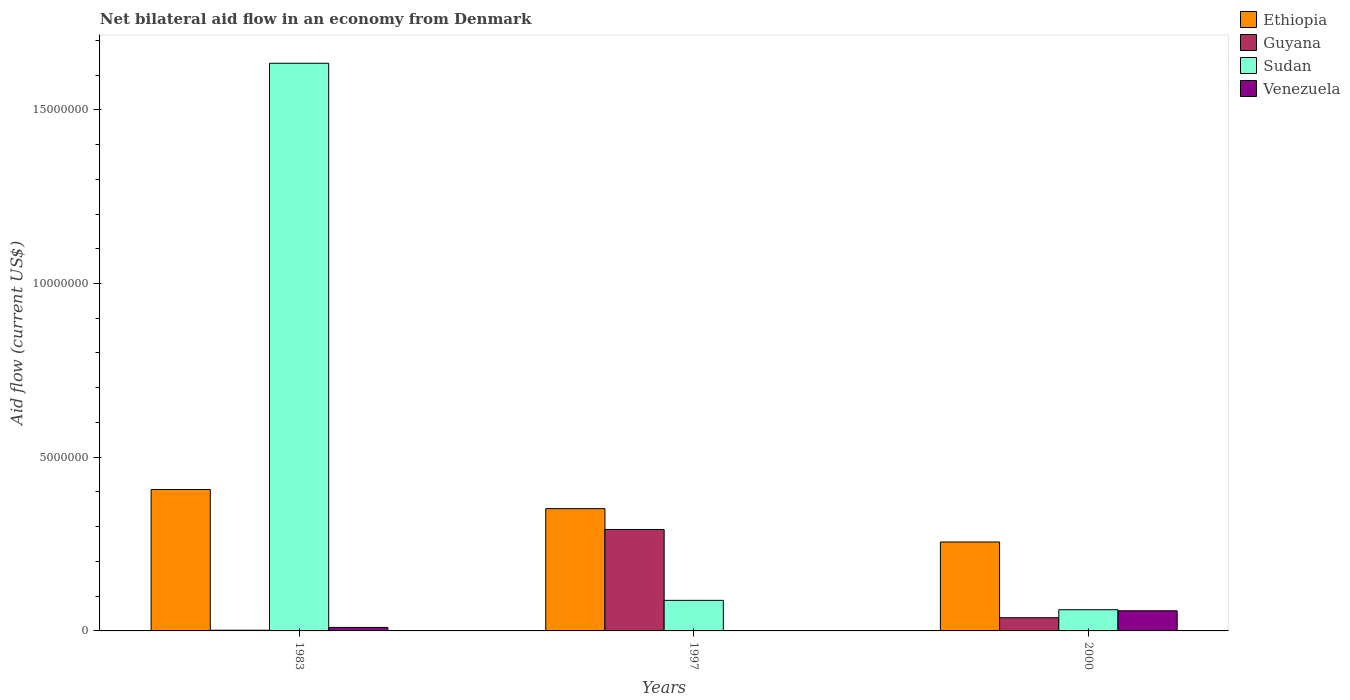How many different coloured bars are there?
Make the answer very short. 4. How many groups of bars are there?
Your response must be concise. 3. Are the number of bars per tick equal to the number of legend labels?
Provide a short and direct response. Yes. Are the number of bars on each tick of the X-axis equal?
Ensure brevity in your answer.  Yes. How many bars are there on the 1st tick from the left?
Keep it short and to the point. 4. How many bars are there on the 1st tick from the right?
Provide a succinct answer. 4. What is the label of the 1st group of bars from the left?
Make the answer very short. 1983. What is the net bilateral aid flow in Sudan in 1997?
Provide a succinct answer. 8.80e+05. Across all years, what is the maximum net bilateral aid flow in Guyana?
Make the answer very short. 2.92e+06. Across all years, what is the minimum net bilateral aid flow in Ethiopia?
Offer a very short reply. 2.56e+06. In which year was the net bilateral aid flow in Guyana maximum?
Give a very brief answer. 1997. In which year was the net bilateral aid flow in Sudan minimum?
Your response must be concise. 2000. What is the total net bilateral aid flow in Venezuela in the graph?
Provide a succinct answer. 6.90e+05. What is the difference between the net bilateral aid flow in Sudan in 2000 and the net bilateral aid flow in Venezuela in 1983?
Make the answer very short. 5.10e+05. What is the average net bilateral aid flow in Sudan per year?
Ensure brevity in your answer.  5.94e+06. In the year 1997, what is the difference between the net bilateral aid flow in Ethiopia and net bilateral aid flow in Sudan?
Make the answer very short. 2.64e+06. What is the ratio of the net bilateral aid flow in Guyana in 1997 to that in 2000?
Keep it short and to the point. 7.68. Is the difference between the net bilateral aid flow in Ethiopia in 1983 and 1997 greater than the difference between the net bilateral aid flow in Sudan in 1983 and 1997?
Make the answer very short. No. What is the difference between the highest and the second highest net bilateral aid flow in Guyana?
Your answer should be very brief. 2.54e+06. What is the difference between the highest and the lowest net bilateral aid flow in Venezuela?
Offer a terse response. 5.70e+05. Is the sum of the net bilateral aid flow in Venezuela in 1983 and 1997 greater than the maximum net bilateral aid flow in Guyana across all years?
Offer a terse response. No. What does the 1st bar from the left in 1983 represents?
Your answer should be compact. Ethiopia. What does the 3rd bar from the right in 1997 represents?
Your response must be concise. Guyana. Are the values on the major ticks of Y-axis written in scientific E-notation?
Your answer should be compact. No. Does the graph contain grids?
Provide a succinct answer. No. Where does the legend appear in the graph?
Ensure brevity in your answer.  Top right. What is the title of the graph?
Make the answer very short. Net bilateral aid flow in an economy from Denmark. What is the label or title of the Y-axis?
Offer a terse response. Aid flow (current US$). What is the Aid flow (current US$) in Ethiopia in 1983?
Give a very brief answer. 4.07e+06. What is the Aid flow (current US$) of Guyana in 1983?
Your response must be concise. 2.00e+04. What is the Aid flow (current US$) of Sudan in 1983?
Offer a very short reply. 1.63e+07. What is the Aid flow (current US$) of Venezuela in 1983?
Keep it short and to the point. 1.00e+05. What is the Aid flow (current US$) in Ethiopia in 1997?
Provide a short and direct response. 3.52e+06. What is the Aid flow (current US$) in Guyana in 1997?
Provide a succinct answer. 2.92e+06. What is the Aid flow (current US$) in Sudan in 1997?
Ensure brevity in your answer.  8.80e+05. What is the Aid flow (current US$) in Ethiopia in 2000?
Give a very brief answer. 2.56e+06. What is the Aid flow (current US$) of Venezuela in 2000?
Offer a terse response. 5.80e+05. Across all years, what is the maximum Aid flow (current US$) in Ethiopia?
Give a very brief answer. 4.07e+06. Across all years, what is the maximum Aid flow (current US$) of Guyana?
Your answer should be very brief. 2.92e+06. Across all years, what is the maximum Aid flow (current US$) of Sudan?
Your answer should be compact. 1.63e+07. Across all years, what is the maximum Aid flow (current US$) in Venezuela?
Make the answer very short. 5.80e+05. Across all years, what is the minimum Aid flow (current US$) in Ethiopia?
Your response must be concise. 2.56e+06. What is the total Aid flow (current US$) of Ethiopia in the graph?
Ensure brevity in your answer.  1.02e+07. What is the total Aid flow (current US$) of Guyana in the graph?
Keep it short and to the point. 3.32e+06. What is the total Aid flow (current US$) of Sudan in the graph?
Offer a terse response. 1.78e+07. What is the total Aid flow (current US$) in Venezuela in the graph?
Make the answer very short. 6.90e+05. What is the difference between the Aid flow (current US$) of Guyana in 1983 and that in 1997?
Keep it short and to the point. -2.90e+06. What is the difference between the Aid flow (current US$) in Sudan in 1983 and that in 1997?
Offer a very short reply. 1.55e+07. What is the difference between the Aid flow (current US$) in Venezuela in 1983 and that in 1997?
Keep it short and to the point. 9.00e+04. What is the difference between the Aid flow (current US$) of Ethiopia in 1983 and that in 2000?
Your response must be concise. 1.51e+06. What is the difference between the Aid flow (current US$) of Guyana in 1983 and that in 2000?
Make the answer very short. -3.60e+05. What is the difference between the Aid flow (current US$) in Sudan in 1983 and that in 2000?
Your answer should be compact. 1.57e+07. What is the difference between the Aid flow (current US$) in Venezuela in 1983 and that in 2000?
Keep it short and to the point. -4.80e+05. What is the difference between the Aid flow (current US$) in Ethiopia in 1997 and that in 2000?
Your response must be concise. 9.60e+05. What is the difference between the Aid flow (current US$) in Guyana in 1997 and that in 2000?
Ensure brevity in your answer.  2.54e+06. What is the difference between the Aid flow (current US$) in Venezuela in 1997 and that in 2000?
Ensure brevity in your answer.  -5.70e+05. What is the difference between the Aid flow (current US$) in Ethiopia in 1983 and the Aid flow (current US$) in Guyana in 1997?
Ensure brevity in your answer.  1.15e+06. What is the difference between the Aid flow (current US$) of Ethiopia in 1983 and the Aid flow (current US$) of Sudan in 1997?
Provide a short and direct response. 3.19e+06. What is the difference between the Aid flow (current US$) in Ethiopia in 1983 and the Aid flow (current US$) in Venezuela in 1997?
Offer a terse response. 4.06e+06. What is the difference between the Aid flow (current US$) of Guyana in 1983 and the Aid flow (current US$) of Sudan in 1997?
Your answer should be very brief. -8.60e+05. What is the difference between the Aid flow (current US$) in Guyana in 1983 and the Aid flow (current US$) in Venezuela in 1997?
Offer a very short reply. 10000. What is the difference between the Aid flow (current US$) in Sudan in 1983 and the Aid flow (current US$) in Venezuela in 1997?
Give a very brief answer. 1.63e+07. What is the difference between the Aid flow (current US$) of Ethiopia in 1983 and the Aid flow (current US$) of Guyana in 2000?
Offer a terse response. 3.69e+06. What is the difference between the Aid flow (current US$) in Ethiopia in 1983 and the Aid flow (current US$) in Sudan in 2000?
Your answer should be very brief. 3.46e+06. What is the difference between the Aid flow (current US$) of Ethiopia in 1983 and the Aid flow (current US$) of Venezuela in 2000?
Give a very brief answer. 3.49e+06. What is the difference between the Aid flow (current US$) in Guyana in 1983 and the Aid flow (current US$) in Sudan in 2000?
Provide a succinct answer. -5.90e+05. What is the difference between the Aid flow (current US$) in Guyana in 1983 and the Aid flow (current US$) in Venezuela in 2000?
Offer a very short reply. -5.60e+05. What is the difference between the Aid flow (current US$) of Sudan in 1983 and the Aid flow (current US$) of Venezuela in 2000?
Offer a terse response. 1.58e+07. What is the difference between the Aid flow (current US$) in Ethiopia in 1997 and the Aid flow (current US$) in Guyana in 2000?
Your response must be concise. 3.14e+06. What is the difference between the Aid flow (current US$) of Ethiopia in 1997 and the Aid flow (current US$) of Sudan in 2000?
Your response must be concise. 2.91e+06. What is the difference between the Aid flow (current US$) in Ethiopia in 1997 and the Aid flow (current US$) in Venezuela in 2000?
Ensure brevity in your answer.  2.94e+06. What is the difference between the Aid flow (current US$) in Guyana in 1997 and the Aid flow (current US$) in Sudan in 2000?
Your response must be concise. 2.31e+06. What is the difference between the Aid flow (current US$) in Guyana in 1997 and the Aid flow (current US$) in Venezuela in 2000?
Your response must be concise. 2.34e+06. What is the average Aid flow (current US$) of Ethiopia per year?
Give a very brief answer. 3.38e+06. What is the average Aid flow (current US$) in Guyana per year?
Provide a succinct answer. 1.11e+06. What is the average Aid flow (current US$) in Sudan per year?
Give a very brief answer. 5.94e+06. What is the average Aid flow (current US$) in Venezuela per year?
Offer a very short reply. 2.30e+05. In the year 1983, what is the difference between the Aid flow (current US$) of Ethiopia and Aid flow (current US$) of Guyana?
Your answer should be compact. 4.05e+06. In the year 1983, what is the difference between the Aid flow (current US$) in Ethiopia and Aid flow (current US$) in Sudan?
Offer a terse response. -1.23e+07. In the year 1983, what is the difference between the Aid flow (current US$) in Ethiopia and Aid flow (current US$) in Venezuela?
Keep it short and to the point. 3.97e+06. In the year 1983, what is the difference between the Aid flow (current US$) of Guyana and Aid flow (current US$) of Sudan?
Ensure brevity in your answer.  -1.63e+07. In the year 1983, what is the difference between the Aid flow (current US$) in Guyana and Aid flow (current US$) in Venezuela?
Your answer should be very brief. -8.00e+04. In the year 1983, what is the difference between the Aid flow (current US$) of Sudan and Aid flow (current US$) of Venezuela?
Your response must be concise. 1.62e+07. In the year 1997, what is the difference between the Aid flow (current US$) of Ethiopia and Aid flow (current US$) of Sudan?
Your response must be concise. 2.64e+06. In the year 1997, what is the difference between the Aid flow (current US$) of Ethiopia and Aid flow (current US$) of Venezuela?
Give a very brief answer. 3.51e+06. In the year 1997, what is the difference between the Aid flow (current US$) of Guyana and Aid flow (current US$) of Sudan?
Your response must be concise. 2.04e+06. In the year 1997, what is the difference between the Aid flow (current US$) in Guyana and Aid flow (current US$) in Venezuela?
Provide a succinct answer. 2.91e+06. In the year 1997, what is the difference between the Aid flow (current US$) in Sudan and Aid flow (current US$) in Venezuela?
Your response must be concise. 8.70e+05. In the year 2000, what is the difference between the Aid flow (current US$) in Ethiopia and Aid flow (current US$) in Guyana?
Your response must be concise. 2.18e+06. In the year 2000, what is the difference between the Aid flow (current US$) in Ethiopia and Aid flow (current US$) in Sudan?
Provide a succinct answer. 1.95e+06. In the year 2000, what is the difference between the Aid flow (current US$) in Ethiopia and Aid flow (current US$) in Venezuela?
Your response must be concise. 1.98e+06. In the year 2000, what is the difference between the Aid flow (current US$) in Guyana and Aid flow (current US$) in Sudan?
Your response must be concise. -2.30e+05. What is the ratio of the Aid flow (current US$) in Ethiopia in 1983 to that in 1997?
Make the answer very short. 1.16. What is the ratio of the Aid flow (current US$) of Guyana in 1983 to that in 1997?
Your response must be concise. 0.01. What is the ratio of the Aid flow (current US$) of Sudan in 1983 to that in 1997?
Provide a succinct answer. 18.57. What is the ratio of the Aid flow (current US$) of Ethiopia in 1983 to that in 2000?
Your answer should be compact. 1.59. What is the ratio of the Aid flow (current US$) of Guyana in 1983 to that in 2000?
Offer a terse response. 0.05. What is the ratio of the Aid flow (current US$) in Sudan in 1983 to that in 2000?
Offer a very short reply. 26.79. What is the ratio of the Aid flow (current US$) in Venezuela in 1983 to that in 2000?
Provide a succinct answer. 0.17. What is the ratio of the Aid flow (current US$) of Ethiopia in 1997 to that in 2000?
Offer a very short reply. 1.38. What is the ratio of the Aid flow (current US$) of Guyana in 1997 to that in 2000?
Offer a very short reply. 7.68. What is the ratio of the Aid flow (current US$) of Sudan in 1997 to that in 2000?
Your answer should be very brief. 1.44. What is the ratio of the Aid flow (current US$) of Venezuela in 1997 to that in 2000?
Your answer should be very brief. 0.02. What is the difference between the highest and the second highest Aid flow (current US$) in Ethiopia?
Offer a very short reply. 5.50e+05. What is the difference between the highest and the second highest Aid flow (current US$) in Guyana?
Provide a succinct answer. 2.54e+06. What is the difference between the highest and the second highest Aid flow (current US$) in Sudan?
Offer a terse response. 1.55e+07. What is the difference between the highest and the lowest Aid flow (current US$) of Ethiopia?
Provide a succinct answer. 1.51e+06. What is the difference between the highest and the lowest Aid flow (current US$) of Guyana?
Offer a very short reply. 2.90e+06. What is the difference between the highest and the lowest Aid flow (current US$) in Sudan?
Offer a terse response. 1.57e+07. What is the difference between the highest and the lowest Aid flow (current US$) in Venezuela?
Your answer should be compact. 5.70e+05. 